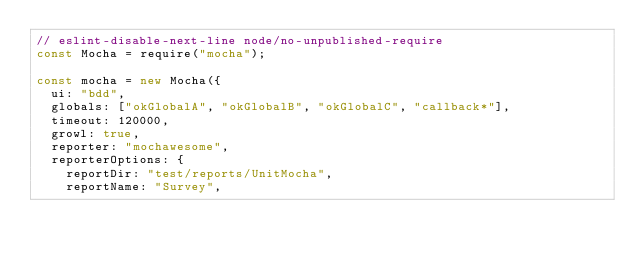Convert code to text. <code><loc_0><loc_0><loc_500><loc_500><_JavaScript_>// eslint-disable-next-line node/no-unpublished-require
const Mocha = require("mocha");

const mocha = new Mocha({
  ui: "bdd",
  globals: ["okGlobalA", "okGlobalB", "okGlobalC", "callback*"],
  timeout: 120000,
  growl: true,
  reporter: "mochawesome",
  reporterOptions: {
    reportDir: "test/reports/UnitMocha",
    reportName: "Survey",</code> 